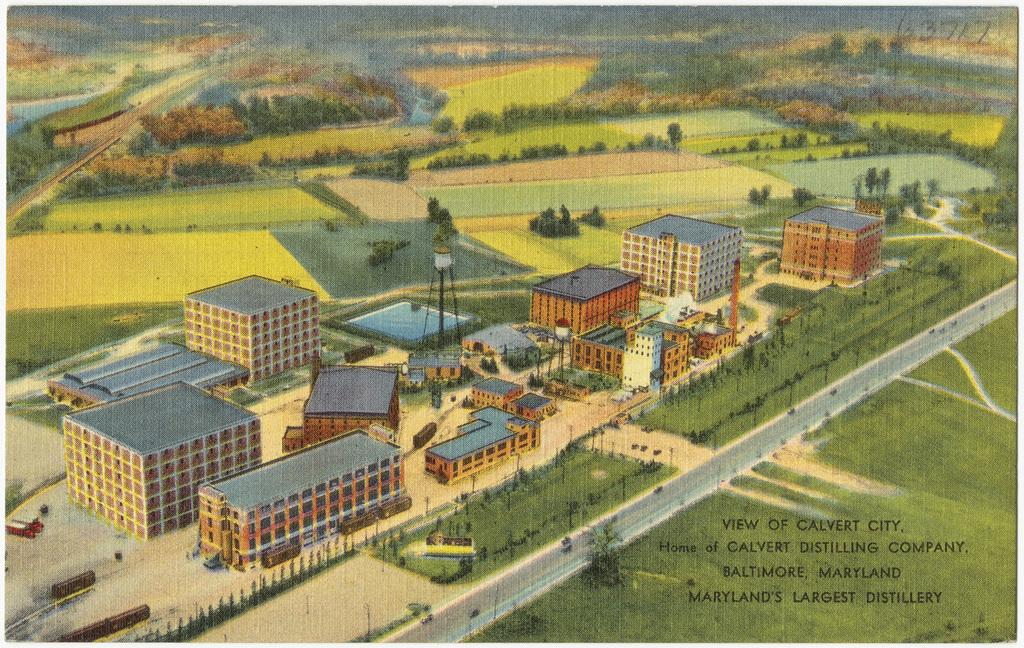What type of artwork is depicted in the image? The image is a painting. What can be seen in the center of the painting? There are buildings in the center of the painting. What is another feature of the painting? There is a road in the painting. What type of vegetation is present in the painting? There are trees and grass in the painting. How many geese are walking on the road in the painting? There are no geese present in the painting; it only features buildings, a road, trees, and grass. 